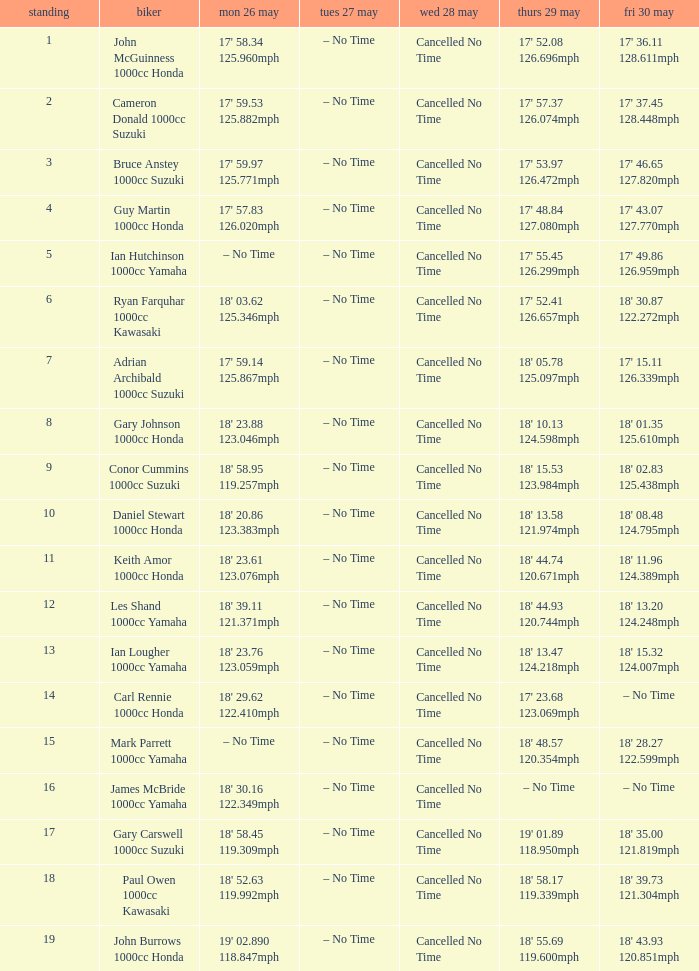What is the numbr for fri may 30 and mon may 26 is 19' 02.890 118.847mph? 18' 43.93 120.851mph. 